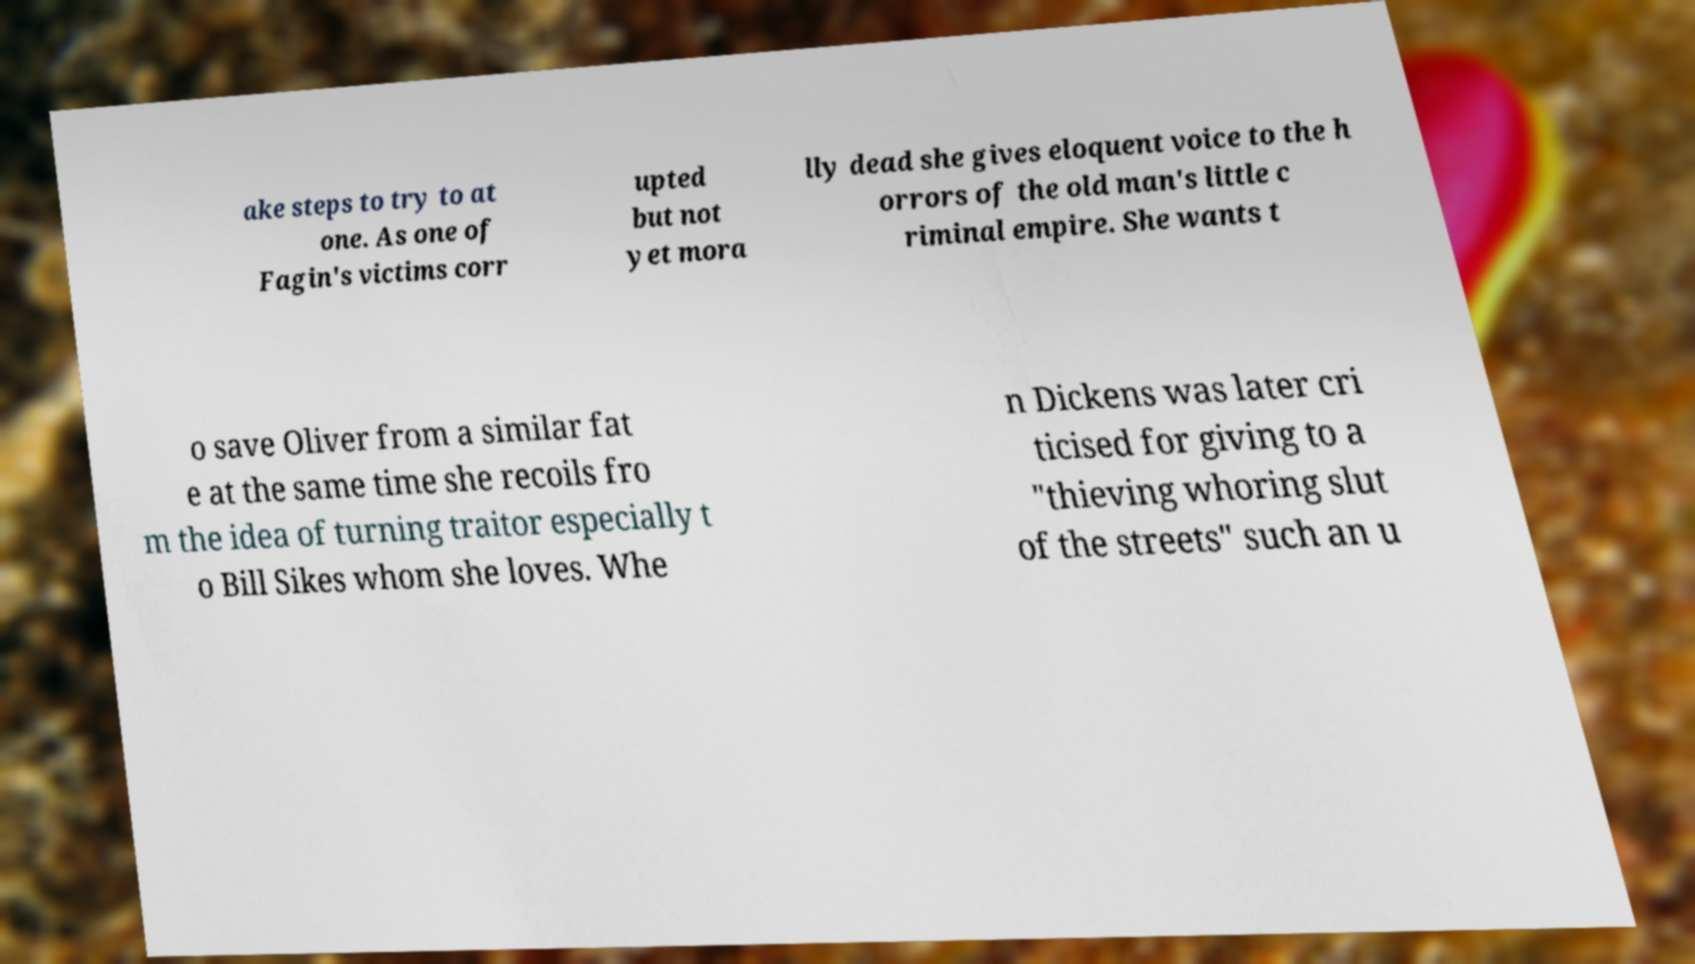Please read and relay the text visible in this image. What does it say? ake steps to try to at one. As one of Fagin's victims corr upted but not yet mora lly dead she gives eloquent voice to the h orrors of the old man's little c riminal empire. She wants t o save Oliver from a similar fat e at the same time she recoils fro m the idea of turning traitor especially t o Bill Sikes whom she loves. Whe n Dickens was later cri ticised for giving to a "thieving whoring slut of the streets" such an u 